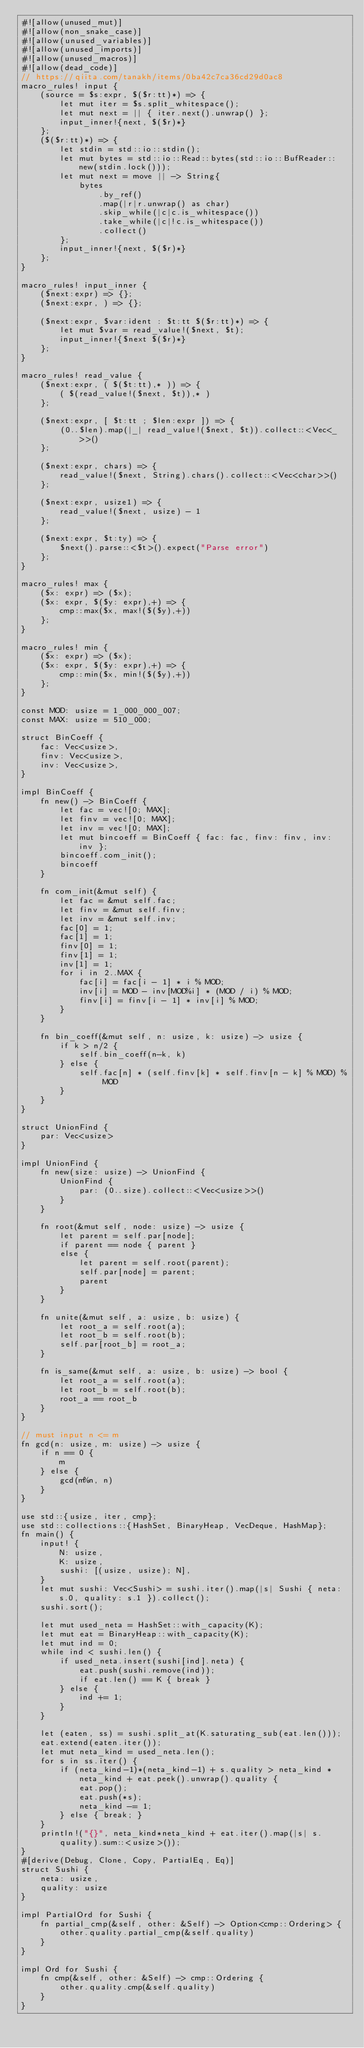<code> <loc_0><loc_0><loc_500><loc_500><_Rust_>#![allow(unused_mut)]
#![allow(non_snake_case)]
#![allow(unused_variables)]
#![allow(unused_imports)]
#![allow(unused_macros)]
#![allow(dead_code)]
// https://qiita.com/tanakh/items/0ba42c7ca36cd29d0ac8
macro_rules! input {
    (source = $s:expr, $($r:tt)*) => {
        let mut iter = $s.split_whitespace();
        let mut next = || { iter.next().unwrap() };
        input_inner!{next, $($r)*}
    };
    ($($r:tt)*) => {
        let stdin = std::io::stdin();
        let mut bytes = std::io::Read::bytes(std::io::BufReader::new(stdin.lock()));
        let mut next = move || -> String{
            bytes
                .by_ref()
                .map(|r|r.unwrap() as char)
                .skip_while(|c|c.is_whitespace())
                .take_while(|c|!c.is_whitespace())
                .collect()
        };
        input_inner!{next, $($r)*}
    };
}

macro_rules! input_inner {
    ($next:expr) => {};
    ($next:expr, ) => {};

    ($next:expr, $var:ident : $t:tt $($r:tt)*) => {
        let mut $var = read_value!($next, $t);
        input_inner!{$next $($r)*}
    };
}

macro_rules! read_value {
    ($next:expr, ( $($t:tt),* )) => {
        ( $(read_value!($next, $t)),* )
    };

    ($next:expr, [ $t:tt ; $len:expr ]) => {
        (0..$len).map(|_| read_value!($next, $t)).collect::<Vec<_>>()
    };

    ($next:expr, chars) => {
        read_value!($next, String).chars().collect::<Vec<char>>()
    };

    ($next:expr, usize1) => {
        read_value!($next, usize) - 1
    };

    ($next:expr, $t:ty) => {
        $next().parse::<$t>().expect("Parse error")
    };
}

macro_rules! max {
    ($x: expr) => ($x);
    ($x: expr, $($y: expr),+) => {
        cmp::max($x, max!($($y),+))
    };
}

macro_rules! min {
    ($x: expr) => ($x);
    ($x: expr, $($y: expr),+) => {
        cmp::min($x, min!($($y),+))
    };
}

const MOD: usize = 1_000_000_007;
const MAX: usize = 510_000;

struct BinCoeff {
    fac: Vec<usize>,
    finv: Vec<usize>,
    inv: Vec<usize>,
}

impl BinCoeff {
    fn new() -> BinCoeff {
        let fac = vec![0; MAX];
        let finv = vec![0; MAX];
        let inv = vec![0; MAX];
        let mut bincoeff = BinCoeff { fac: fac, finv: finv, inv: inv };
        bincoeff.com_init();
        bincoeff
    }

    fn com_init(&mut self) {
        let fac = &mut self.fac;
        let finv = &mut self.finv;
        let inv = &mut self.inv;
        fac[0] = 1;
        fac[1] = 1;
        finv[0] = 1;
        finv[1] = 1;
        inv[1] = 1;
        for i in 2..MAX {
            fac[i] = fac[i - 1] * i % MOD;
            inv[i] = MOD - inv[MOD%i] * (MOD / i) % MOD;
            finv[i] = finv[i - 1] * inv[i] % MOD;
        }
    }

    fn bin_coeff(&mut self, n: usize, k: usize) -> usize {
        if k > n/2 {
            self.bin_coeff(n-k, k)
        } else {
            self.fac[n] * (self.finv[k] * self.finv[n - k] % MOD) % MOD
        }
    }
}

struct UnionFind {
    par: Vec<usize>
}

impl UnionFind {
    fn new(size: usize) -> UnionFind {
        UnionFind {
            par: (0..size).collect::<Vec<usize>>()
        }
    }

    fn root(&mut self, node: usize) -> usize {
        let parent = self.par[node];
        if parent == node { parent }
        else {
            let parent = self.root(parent);
            self.par[node] = parent;
            parent
        }
    }

    fn unite(&mut self, a: usize, b: usize) {
        let root_a = self.root(a);
        let root_b = self.root(b);
        self.par[root_b] = root_a;
    }

    fn is_same(&mut self, a: usize, b: usize) -> bool {
        let root_a = self.root(a);
        let root_b = self.root(b);
        root_a == root_b
    }
}

// must input n <= m
fn gcd(n: usize, m: usize) -> usize {
    if n == 0 {
        m
    } else {
        gcd(m%n, n)
    }
}

use std::{usize, iter, cmp};
use std::collections::{HashSet, BinaryHeap, VecDeque, HashMap};
fn main() {
    input! {
        N: usize,
        K: usize,
        sushi: [(usize, usize); N],
    }
    let mut sushi: Vec<Sushi> = sushi.iter().map(|s| Sushi { neta: s.0, quality: s.1 }).collect();
    sushi.sort();

    let mut used_neta = HashSet::with_capacity(K);
    let mut eat = BinaryHeap::with_capacity(K);
    let mut ind = 0;
    while ind < sushi.len() {
        if used_neta.insert(sushi[ind].neta) {
            eat.push(sushi.remove(ind));
            if eat.len() == K { break }
        } else {
            ind += 1;
        }
    }

    let (eaten, ss) = sushi.split_at(K.saturating_sub(eat.len()));
    eat.extend(eaten.iter());
    let mut neta_kind = used_neta.len();
    for s in ss.iter() {
        if (neta_kind-1)*(neta_kind-1) + s.quality > neta_kind * neta_kind + eat.peek().unwrap().quality {
            eat.pop();
            eat.push(*s);
            neta_kind -= 1;
        } else { break; }
    }
    println!("{}", neta_kind*neta_kind + eat.iter().map(|s| s.quality).sum::<usize>());
}
#[derive(Debug, Clone, Copy, PartialEq, Eq)]
struct Sushi {
    neta: usize,
    quality: usize
}

impl PartialOrd for Sushi {
    fn partial_cmp(&self, other: &Self) -> Option<cmp::Ordering> {
        other.quality.partial_cmp(&self.quality)
    }
}

impl Ord for Sushi {
    fn cmp(&self, other: &Self) -> cmp::Ordering {
        other.quality.cmp(&self.quality)
    }
}</code> 